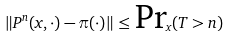<formula> <loc_0><loc_0><loc_500><loc_500>\| P ^ { n } ( x , \cdot ) - \pi ( \cdot ) \| \leq \text {Pr} _ { x } ( T > n )</formula> 